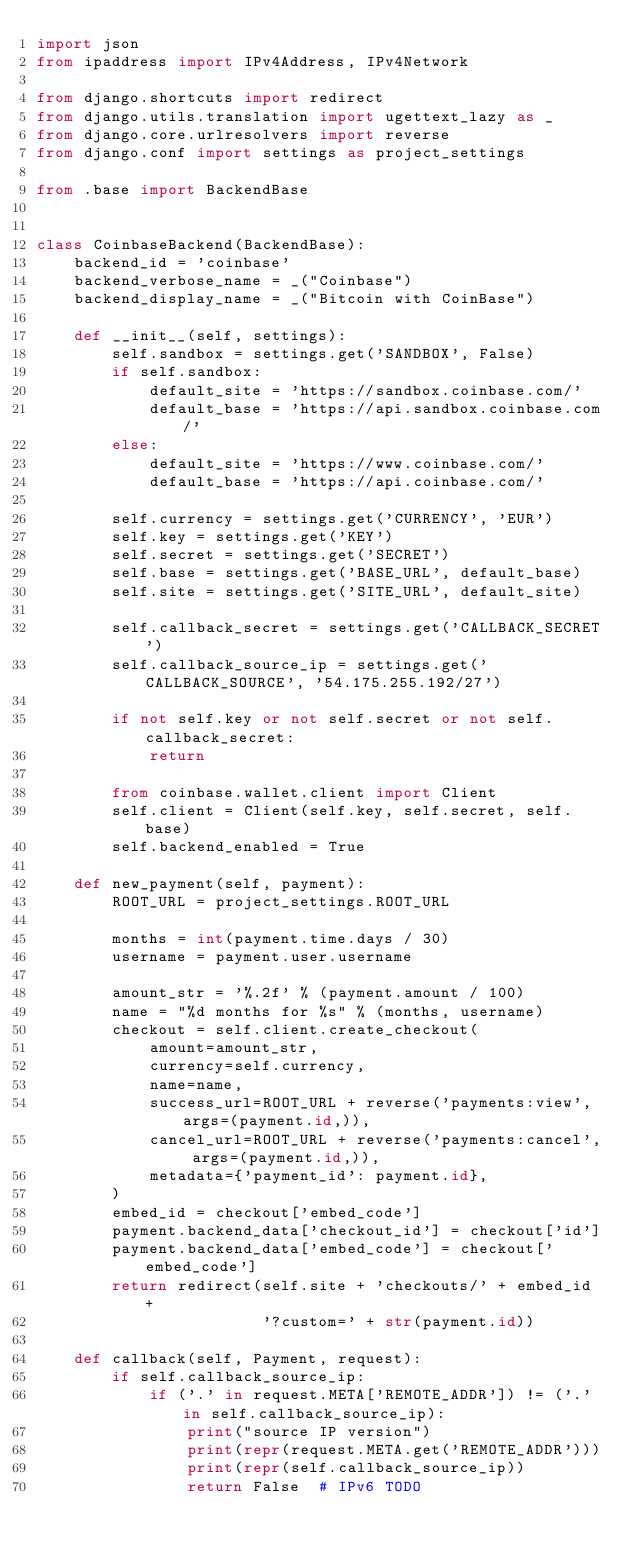Convert code to text. <code><loc_0><loc_0><loc_500><loc_500><_Python_>import json
from ipaddress import IPv4Address, IPv4Network

from django.shortcuts import redirect
from django.utils.translation import ugettext_lazy as _
from django.core.urlresolvers import reverse
from django.conf import settings as project_settings

from .base import BackendBase


class CoinbaseBackend(BackendBase):
    backend_id = 'coinbase'
    backend_verbose_name = _("Coinbase")
    backend_display_name = _("Bitcoin with CoinBase")

    def __init__(self, settings):
        self.sandbox = settings.get('SANDBOX', False)
        if self.sandbox:
            default_site = 'https://sandbox.coinbase.com/'
            default_base = 'https://api.sandbox.coinbase.com/'
        else:
            default_site = 'https://www.coinbase.com/'
            default_base = 'https://api.coinbase.com/'

        self.currency = settings.get('CURRENCY', 'EUR')
        self.key = settings.get('KEY')
        self.secret = settings.get('SECRET')
        self.base = settings.get('BASE_URL', default_base)
        self.site = settings.get('SITE_URL', default_site)

        self.callback_secret = settings.get('CALLBACK_SECRET')
        self.callback_source_ip = settings.get('CALLBACK_SOURCE', '54.175.255.192/27')

        if not self.key or not self.secret or not self.callback_secret:
            return

        from coinbase.wallet.client import Client
        self.client = Client(self.key, self.secret, self.base)
        self.backend_enabled = True

    def new_payment(self, payment):
        ROOT_URL = project_settings.ROOT_URL

        months = int(payment.time.days / 30)
        username = payment.user.username

        amount_str = '%.2f' % (payment.amount / 100)
        name = "%d months for %s" % (months, username)
        checkout = self.client.create_checkout(
            amount=amount_str,
            currency=self.currency,
            name=name,
            success_url=ROOT_URL + reverse('payments:view', args=(payment.id,)),
            cancel_url=ROOT_URL + reverse('payments:cancel', args=(payment.id,)),
            metadata={'payment_id': payment.id},
        )
        embed_id = checkout['embed_code']
        payment.backend_data['checkout_id'] = checkout['id']
        payment.backend_data['embed_code'] = checkout['embed_code']
        return redirect(self.site + 'checkouts/' + embed_id +
                        '?custom=' + str(payment.id))

    def callback(self, Payment, request):
        if self.callback_source_ip:
            if ('.' in request.META['REMOTE_ADDR']) != ('.' in self.callback_source_ip):
                print("source IP version")
                print(repr(request.META.get('REMOTE_ADDR')))
                print(repr(self.callback_source_ip))
                return False  # IPv6 TODO</code> 